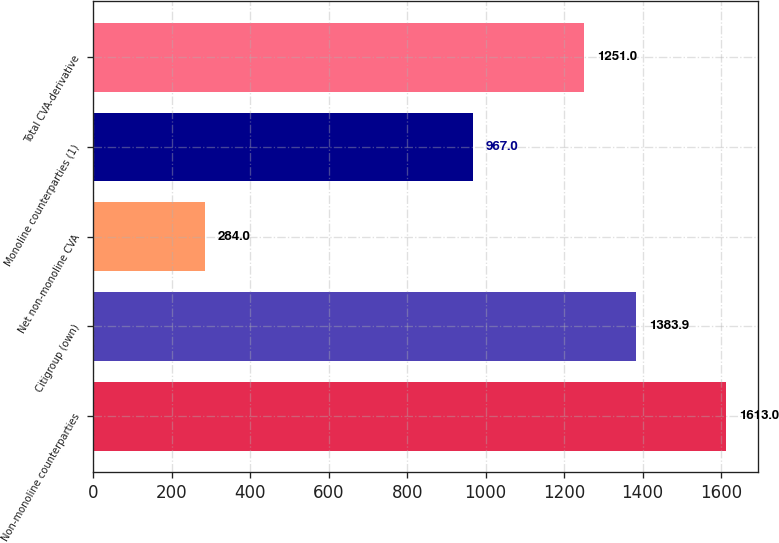Convert chart to OTSL. <chart><loc_0><loc_0><loc_500><loc_500><bar_chart><fcel>Non-monoline counterparties<fcel>Citigroup (own)<fcel>Net non-monoline CVA<fcel>Monoline counterparties (1)<fcel>Total CVA-derivative<nl><fcel>1613<fcel>1383.9<fcel>284<fcel>967<fcel>1251<nl></chart> 